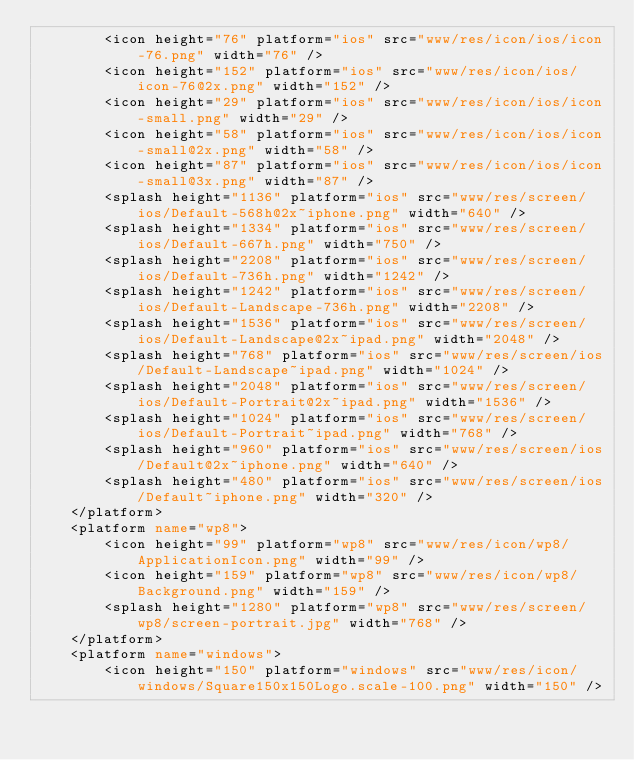<code> <loc_0><loc_0><loc_500><loc_500><_XML_>        <icon height="76" platform="ios" src="www/res/icon/ios/icon-76.png" width="76" />
        <icon height="152" platform="ios" src="www/res/icon/ios/icon-76@2x.png" width="152" />
        <icon height="29" platform="ios" src="www/res/icon/ios/icon-small.png" width="29" />
        <icon height="58" platform="ios" src="www/res/icon/ios/icon-small@2x.png" width="58" />
        <icon height="87" platform="ios" src="www/res/icon/ios/icon-small@3x.png" width="87" />
        <splash height="1136" platform="ios" src="www/res/screen/ios/Default-568h@2x~iphone.png" width="640" />
        <splash height="1334" platform="ios" src="www/res/screen/ios/Default-667h.png" width="750" />
        <splash height="2208" platform="ios" src="www/res/screen/ios/Default-736h.png" width="1242" />
        <splash height="1242" platform="ios" src="www/res/screen/ios/Default-Landscape-736h.png" width="2208" />
        <splash height="1536" platform="ios" src="www/res/screen/ios/Default-Landscape@2x~ipad.png" width="2048" />
        <splash height="768" platform="ios" src="www/res/screen/ios/Default-Landscape~ipad.png" width="1024" />
        <splash height="2048" platform="ios" src="www/res/screen/ios/Default-Portrait@2x~ipad.png" width="1536" />
        <splash height="1024" platform="ios" src="www/res/screen/ios/Default-Portrait~ipad.png" width="768" />
        <splash height="960" platform="ios" src="www/res/screen/ios/Default@2x~iphone.png" width="640" />
        <splash height="480" platform="ios" src="www/res/screen/ios/Default~iphone.png" width="320" />
    </platform>
    <platform name="wp8">
        <icon height="99" platform="wp8" src="www/res/icon/wp8/ApplicationIcon.png" width="99" />
        <icon height="159" platform="wp8" src="www/res/icon/wp8/Background.png" width="159" />
        <splash height="1280" platform="wp8" src="www/res/screen/wp8/screen-portrait.jpg" width="768" />
    </platform>
    <platform name="windows">
        <icon height="150" platform="windows" src="www/res/icon/windows/Square150x150Logo.scale-100.png" width="150" /></code> 